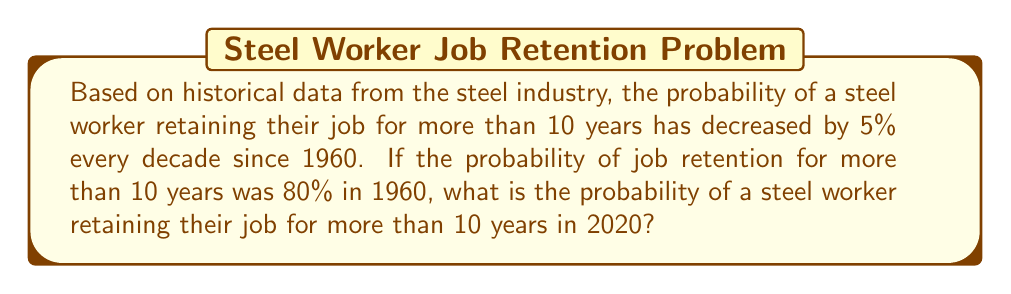Show me your answer to this math problem. Let's approach this step-by-step:

1) First, we need to determine how many decades have passed from 1960 to 2020:
   $$(2020 - 1960) / 10 = 6$$ decades

2) We know that the probability decreases by 5% (or 0.05) each decade.
   So, the total decrease over 6 decades is:
   $$6 \times 0.05 = 0.30$$ or 30%

3) The initial probability in 1960 was 80% or 0.80.

4) To find the probability in 2020, we subtract the total decrease from the initial probability:
   $$0.80 - 0.30 = 0.50$$ or 50%

Therefore, the probability of a steel worker retaining their job for more than 10 years in 2020 is 50% or 0.50.
Answer: 0.50 or 50% 